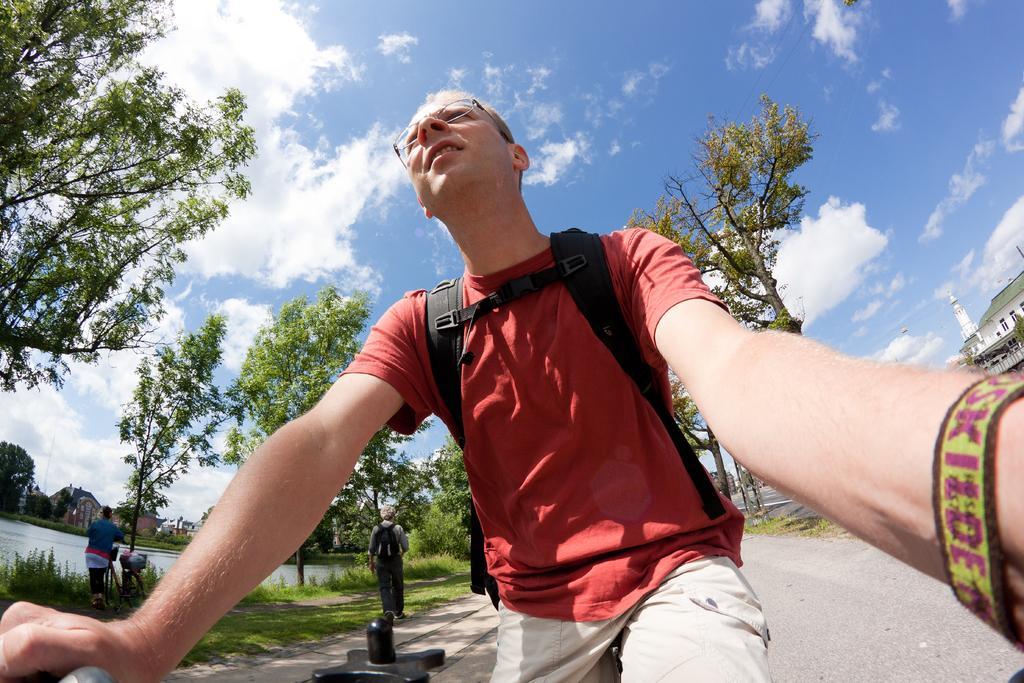Please provide a concise description of this image. In front of the picture, we see a man in the red T-shirt who is wearing the spectacles is riding the bicycle. At the bottom, we see the road. Behind him, we see a man who is wearing a black backpack is walking. On the left side, we see the trees, grass and a woman is standing. Beside her, we see a stand and the water. This water might be in the pond. On the right side, we see a building in white color with a green color roof. There are trees and the buildings in the background. At the top, we see the sky and the clouds. 